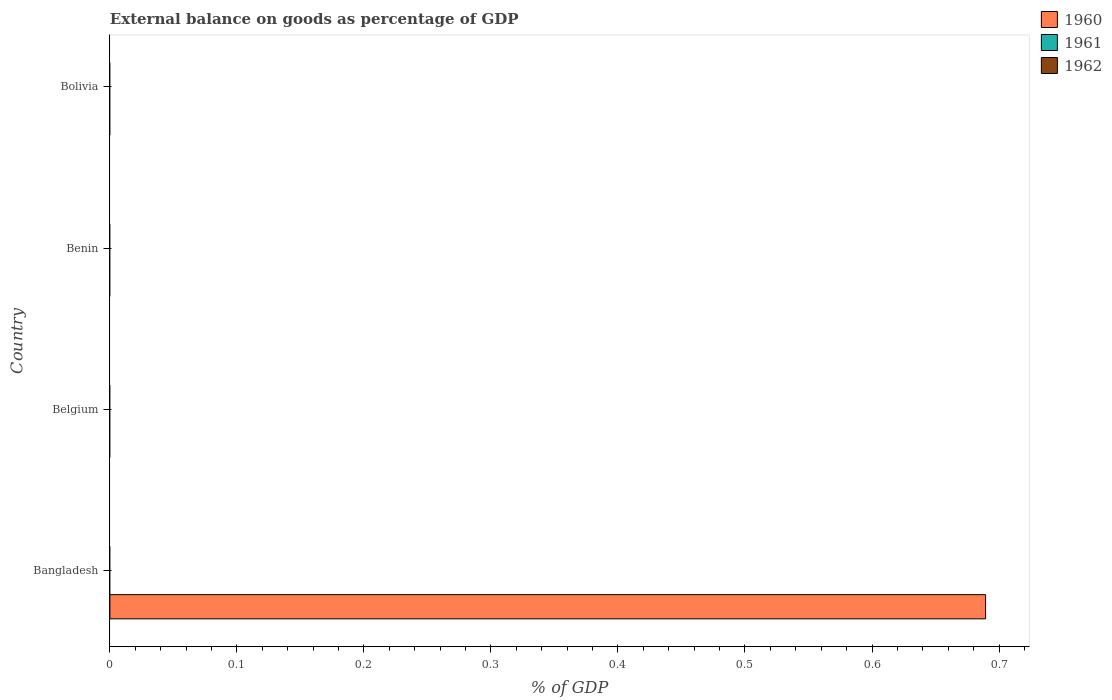How many different coloured bars are there?
Your answer should be very brief. 1. Are the number of bars per tick equal to the number of legend labels?
Provide a short and direct response. No. Across all countries, what is the maximum external balance on goods as percentage of GDP in 1960?
Ensure brevity in your answer.  0.69. In which country was the external balance on goods as percentage of GDP in 1960 maximum?
Offer a terse response. Bangladesh. What is the average external balance on goods as percentage of GDP in 1962 per country?
Your response must be concise. 0. What is the difference between the highest and the lowest external balance on goods as percentage of GDP in 1960?
Your answer should be very brief. 0.69. How many bars are there?
Provide a short and direct response. 1. What is the difference between two consecutive major ticks on the X-axis?
Your response must be concise. 0.1. Are the values on the major ticks of X-axis written in scientific E-notation?
Ensure brevity in your answer.  No. Does the graph contain any zero values?
Your response must be concise. Yes. What is the title of the graph?
Your answer should be very brief. External balance on goods as percentage of GDP. What is the label or title of the X-axis?
Your response must be concise. % of GDP. What is the label or title of the Y-axis?
Your response must be concise. Country. What is the % of GDP in 1960 in Bangladesh?
Ensure brevity in your answer.  0.69. What is the % of GDP in 1962 in Bangladesh?
Offer a terse response. 0. What is the % of GDP in 1960 in Belgium?
Your answer should be compact. 0. What is the % of GDP in 1961 in Benin?
Ensure brevity in your answer.  0. What is the % of GDP in 1960 in Bolivia?
Your response must be concise. 0. Across all countries, what is the maximum % of GDP of 1960?
Make the answer very short. 0.69. Across all countries, what is the minimum % of GDP of 1960?
Your answer should be very brief. 0. What is the total % of GDP of 1960 in the graph?
Give a very brief answer. 0.69. What is the total % of GDP of 1961 in the graph?
Make the answer very short. 0. What is the total % of GDP in 1962 in the graph?
Keep it short and to the point. 0. What is the average % of GDP in 1960 per country?
Give a very brief answer. 0.17. What is the average % of GDP in 1962 per country?
Offer a very short reply. 0. What is the difference between the highest and the lowest % of GDP of 1960?
Provide a short and direct response. 0.69. 